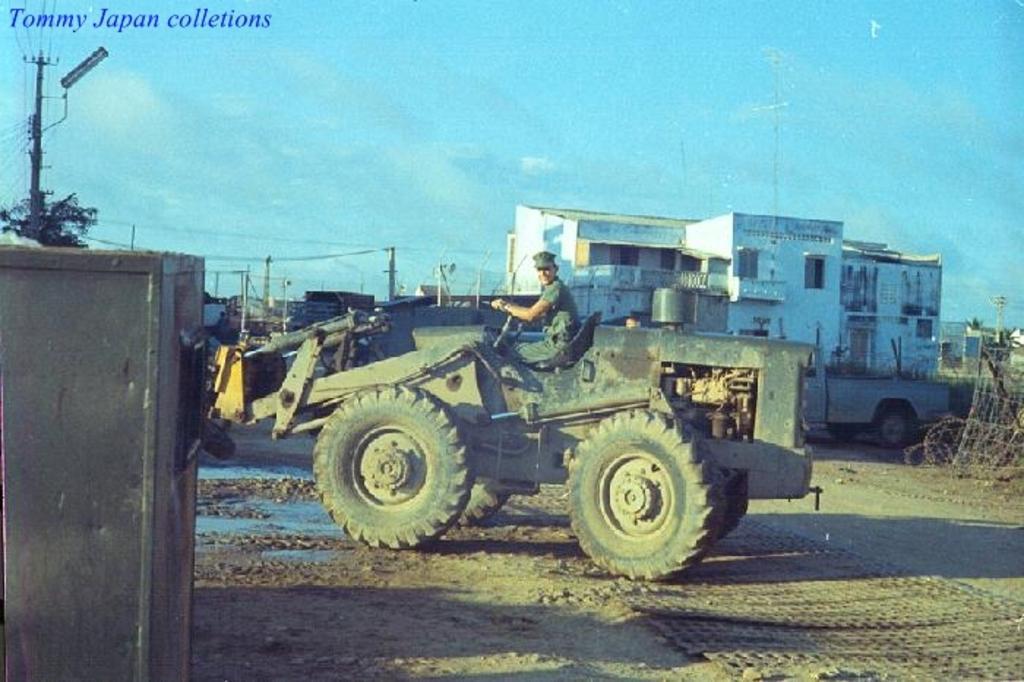In one or two sentences, can you explain what this image depicts? In this image there is a man driving a vehicle on a road, in the background there are houses, poles and wires and the sky, in the bottom left there is a box, in the top left there is text. 